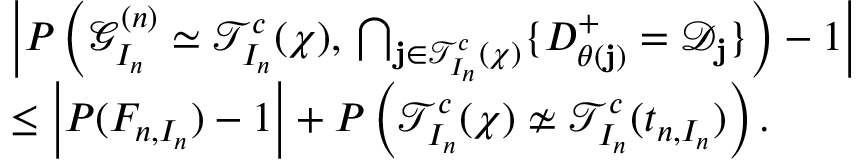<formula> <loc_0><loc_0><loc_500><loc_500>\begin{array} { r l } & { \left | P \left ( \mathcal { G } _ { I _ { n } } ^ { ( n ) } \simeq \mathcal { T } _ { I _ { n } } ^ { c } ( \chi ) , \, \bigcap _ { j \in \mathcal { T } _ { I _ { n } } ^ { c } ( \chi ) } \{ D _ { \theta ( j ) } ^ { + } = \mathcal { D } _ { j } \} \right ) - 1 \right | } \\ & { \leq \left | P ( F _ { n , I _ { n } } ) - 1 \right | + P \left ( \mathcal { T } _ { I _ { n } } ^ { c } ( \chi ) \not \simeq \mathcal { T } _ { I _ { n } } ^ { c } ( t _ { n , I _ { n } } ) \right ) . } \end{array}</formula> 